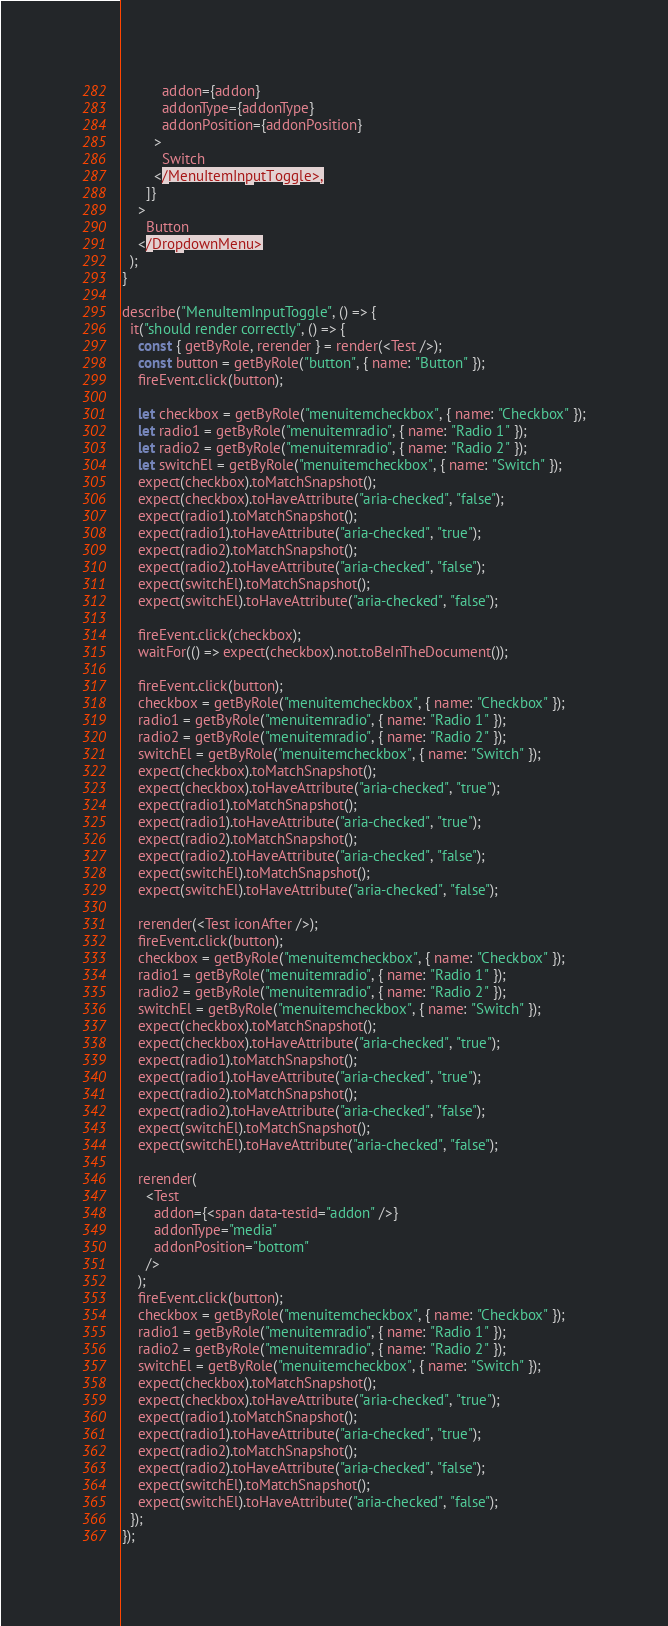<code> <loc_0><loc_0><loc_500><loc_500><_TypeScript_>          addon={addon}
          addonType={addonType}
          addonPosition={addonPosition}
        >
          Switch
        </MenuItemInputToggle>,
      ]}
    >
      Button
    </DropdownMenu>
  );
}

describe("MenuItemInputToggle", () => {
  it("should render correctly", () => {
    const { getByRole, rerender } = render(<Test />);
    const button = getByRole("button", { name: "Button" });
    fireEvent.click(button);

    let checkbox = getByRole("menuitemcheckbox", { name: "Checkbox" });
    let radio1 = getByRole("menuitemradio", { name: "Radio 1" });
    let radio2 = getByRole("menuitemradio", { name: "Radio 2" });
    let switchEl = getByRole("menuitemcheckbox", { name: "Switch" });
    expect(checkbox).toMatchSnapshot();
    expect(checkbox).toHaveAttribute("aria-checked", "false");
    expect(radio1).toMatchSnapshot();
    expect(radio1).toHaveAttribute("aria-checked", "true");
    expect(radio2).toMatchSnapshot();
    expect(radio2).toHaveAttribute("aria-checked", "false");
    expect(switchEl).toMatchSnapshot();
    expect(switchEl).toHaveAttribute("aria-checked", "false");

    fireEvent.click(checkbox);
    waitFor(() => expect(checkbox).not.toBeInTheDocument());

    fireEvent.click(button);
    checkbox = getByRole("menuitemcheckbox", { name: "Checkbox" });
    radio1 = getByRole("menuitemradio", { name: "Radio 1" });
    radio2 = getByRole("menuitemradio", { name: "Radio 2" });
    switchEl = getByRole("menuitemcheckbox", { name: "Switch" });
    expect(checkbox).toMatchSnapshot();
    expect(checkbox).toHaveAttribute("aria-checked", "true");
    expect(radio1).toMatchSnapshot();
    expect(radio1).toHaveAttribute("aria-checked", "true");
    expect(radio2).toMatchSnapshot();
    expect(radio2).toHaveAttribute("aria-checked", "false");
    expect(switchEl).toMatchSnapshot();
    expect(switchEl).toHaveAttribute("aria-checked", "false");

    rerender(<Test iconAfter />);
    fireEvent.click(button);
    checkbox = getByRole("menuitemcheckbox", { name: "Checkbox" });
    radio1 = getByRole("menuitemradio", { name: "Radio 1" });
    radio2 = getByRole("menuitemradio", { name: "Radio 2" });
    switchEl = getByRole("menuitemcheckbox", { name: "Switch" });
    expect(checkbox).toMatchSnapshot();
    expect(checkbox).toHaveAttribute("aria-checked", "true");
    expect(radio1).toMatchSnapshot();
    expect(radio1).toHaveAttribute("aria-checked", "true");
    expect(radio2).toMatchSnapshot();
    expect(radio2).toHaveAttribute("aria-checked", "false");
    expect(switchEl).toMatchSnapshot();
    expect(switchEl).toHaveAttribute("aria-checked", "false");

    rerender(
      <Test
        addon={<span data-testid="addon" />}
        addonType="media"
        addonPosition="bottom"
      />
    );
    fireEvent.click(button);
    checkbox = getByRole("menuitemcheckbox", { name: "Checkbox" });
    radio1 = getByRole("menuitemradio", { name: "Radio 1" });
    radio2 = getByRole("menuitemradio", { name: "Radio 2" });
    switchEl = getByRole("menuitemcheckbox", { name: "Switch" });
    expect(checkbox).toMatchSnapshot();
    expect(checkbox).toHaveAttribute("aria-checked", "true");
    expect(radio1).toMatchSnapshot();
    expect(radio1).toHaveAttribute("aria-checked", "true");
    expect(radio2).toMatchSnapshot();
    expect(radio2).toHaveAttribute("aria-checked", "false");
    expect(switchEl).toMatchSnapshot();
    expect(switchEl).toHaveAttribute("aria-checked", "false");
  });
});
</code> 